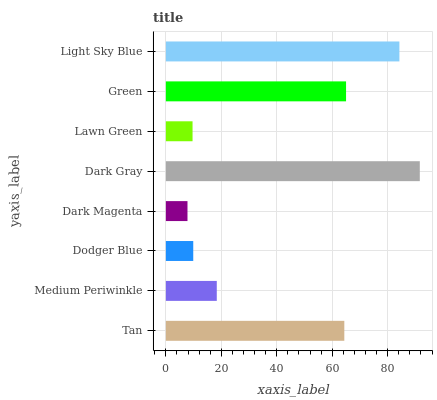Is Dark Magenta the minimum?
Answer yes or no. Yes. Is Dark Gray the maximum?
Answer yes or no. Yes. Is Medium Periwinkle the minimum?
Answer yes or no. No. Is Medium Periwinkle the maximum?
Answer yes or no. No. Is Tan greater than Medium Periwinkle?
Answer yes or no. Yes. Is Medium Periwinkle less than Tan?
Answer yes or no. Yes. Is Medium Periwinkle greater than Tan?
Answer yes or no. No. Is Tan less than Medium Periwinkle?
Answer yes or no. No. Is Tan the high median?
Answer yes or no. Yes. Is Medium Periwinkle the low median?
Answer yes or no. Yes. Is Lawn Green the high median?
Answer yes or no. No. Is Dark Magenta the low median?
Answer yes or no. No. 